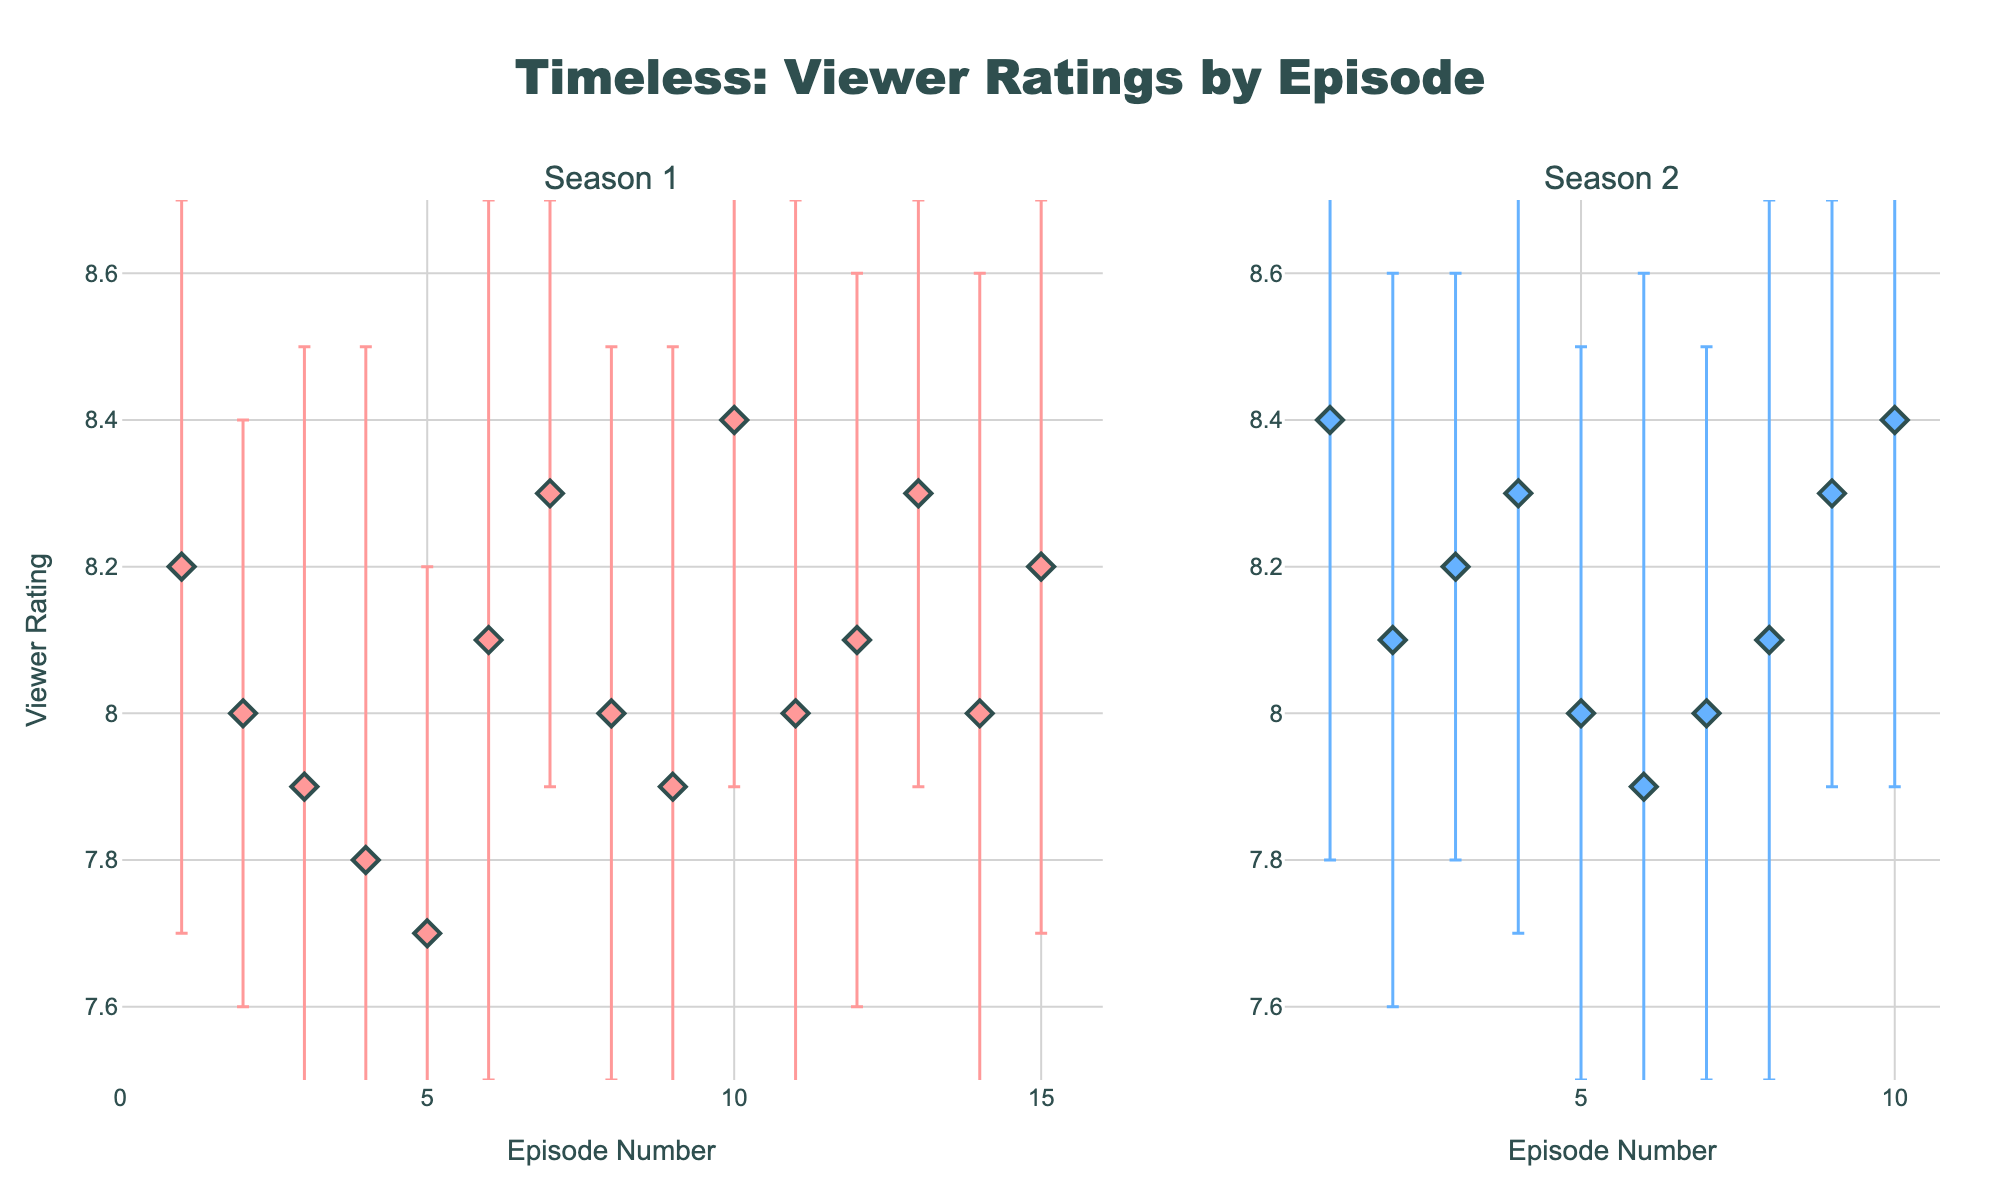What's the title of the figure? The title of the figure is generally found at the top center of the plot. In this case, the title is clearly written above the two subplots.
Answer: Timeless: Viewer Ratings by Episode Which season has the highest average viewer rating? To determine this, calculate the average rating for each season by adding up the ratings for each episode and dividing by the number of episodes in that season.
Answer: Season 2 What is the viewer rating for the "Pilot" episode in Season 1? Find the "Pilot" episode in Season 1 within the plot and read its corresponding viewer rating value on the y-axis.
Answer: 8.2 Which episode has the highest viewer rating in Season 2? Locate the highest point in the Season 2 subplot and identify the episode associated with this point.
Answer: The War to End All Wars and Chinatown How does the standard deviation of "Atomic City" compare to "The Kennedy Curse"? Compare the length of the error bars (vertical lines) for "Atomic City" in Season 1 and "The Kennedy Curse" in Season 2.
Answer: "Atomic City" has a larger standard deviation than "The Kennedy Curse" How many episodes in Season 1 have an average viewer rating above 8.1? Count the number of points in Season 1 subplot where the viewer rating value is greater than 8.1 (above the 8.1 mark on the y-axis).
Answer: 5 Which season has a more consistent rating overall (lower standard deviations)? Determine which season has generally shorter error bars, indicating lower standard deviations and more consistent ratings across episodes.
Answer: Season 1 What is the range of viewer ratings in Season 1? Identify the highest and lowest ratings in the Season 1 subplot, then subtract the lowest rating from the highest rating to find the range.
Answer: 0.7 (8.4 - 7.7) Which episode has the largest error bar in Season 2? Look for the episode in the Season 2 subplot with the longest vertical error bar, indicating the largest standard deviation.
Answer: The Day Reagan Was Shot Are there any episodes in Season 1 and Season 2 with the exact same viewer rating? Compare the viewer ratings of each episode visually in both seasons to see if any points align horizontally.
Answer: Yes, multiple episodes have a rating of 8.0 and 8.1 in both seasons 